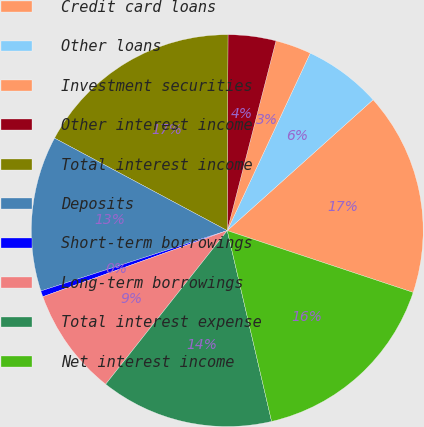<chart> <loc_0><loc_0><loc_500><loc_500><pie_chart><fcel>Credit card loans<fcel>Other loans<fcel>Investment securities<fcel>Other interest income<fcel>Total interest income<fcel>Deposits<fcel>Short-term borrowings<fcel>Long-term borrowings<fcel>Total interest expense<fcel>Net interest income<nl><fcel>16.75%<fcel>6.4%<fcel>2.96%<fcel>3.94%<fcel>17.24%<fcel>12.81%<fcel>0.49%<fcel>8.87%<fcel>14.29%<fcel>16.26%<nl></chart> 